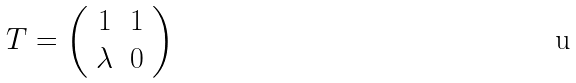<formula> <loc_0><loc_0><loc_500><loc_500>T = \left ( \begin{array} { c c } 1 & 1 \\ \lambda & 0 \end{array} \right )</formula> 